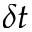<formula> <loc_0><loc_0><loc_500><loc_500>\delta t</formula> 